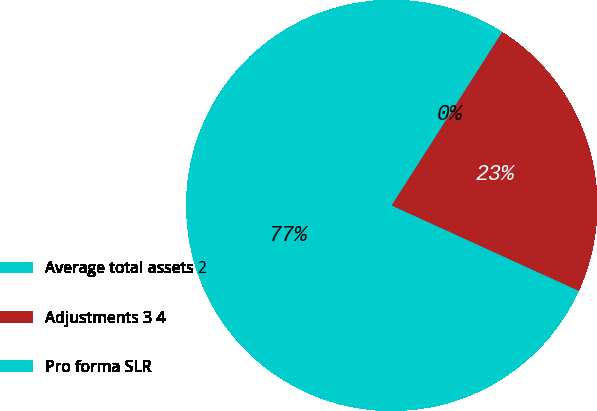Convert chart to OTSL. <chart><loc_0><loc_0><loc_500><loc_500><pie_chart><fcel>Average total assets 2<fcel>Adjustments 3 4<fcel>Pro forma SLR<nl><fcel>77.22%<fcel>22.78%<fcel>0.0%<nl></chart> 